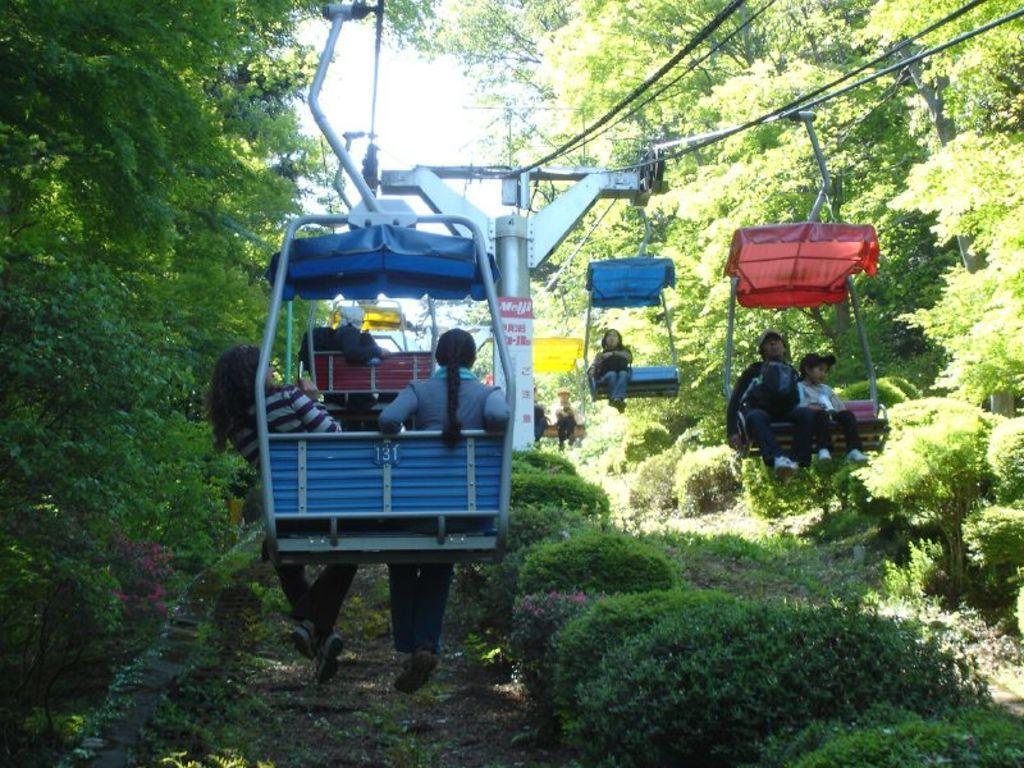Could you give a brief overview of what you see in this image? In this image we can see few people sitting on the rope way, also we can see a pole, ropes, wires, there are some plants, trees, we can also see the sky. 